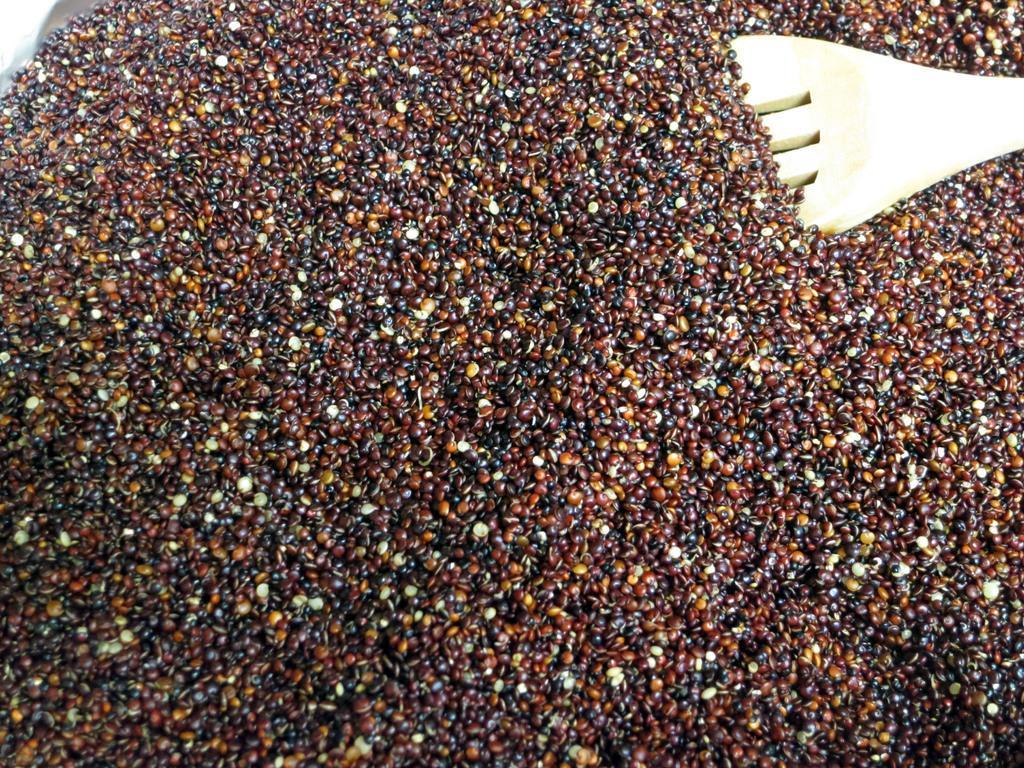Could you give a brief overview of what you see in this image? There are few seeds and there is an object in the right top corner. 